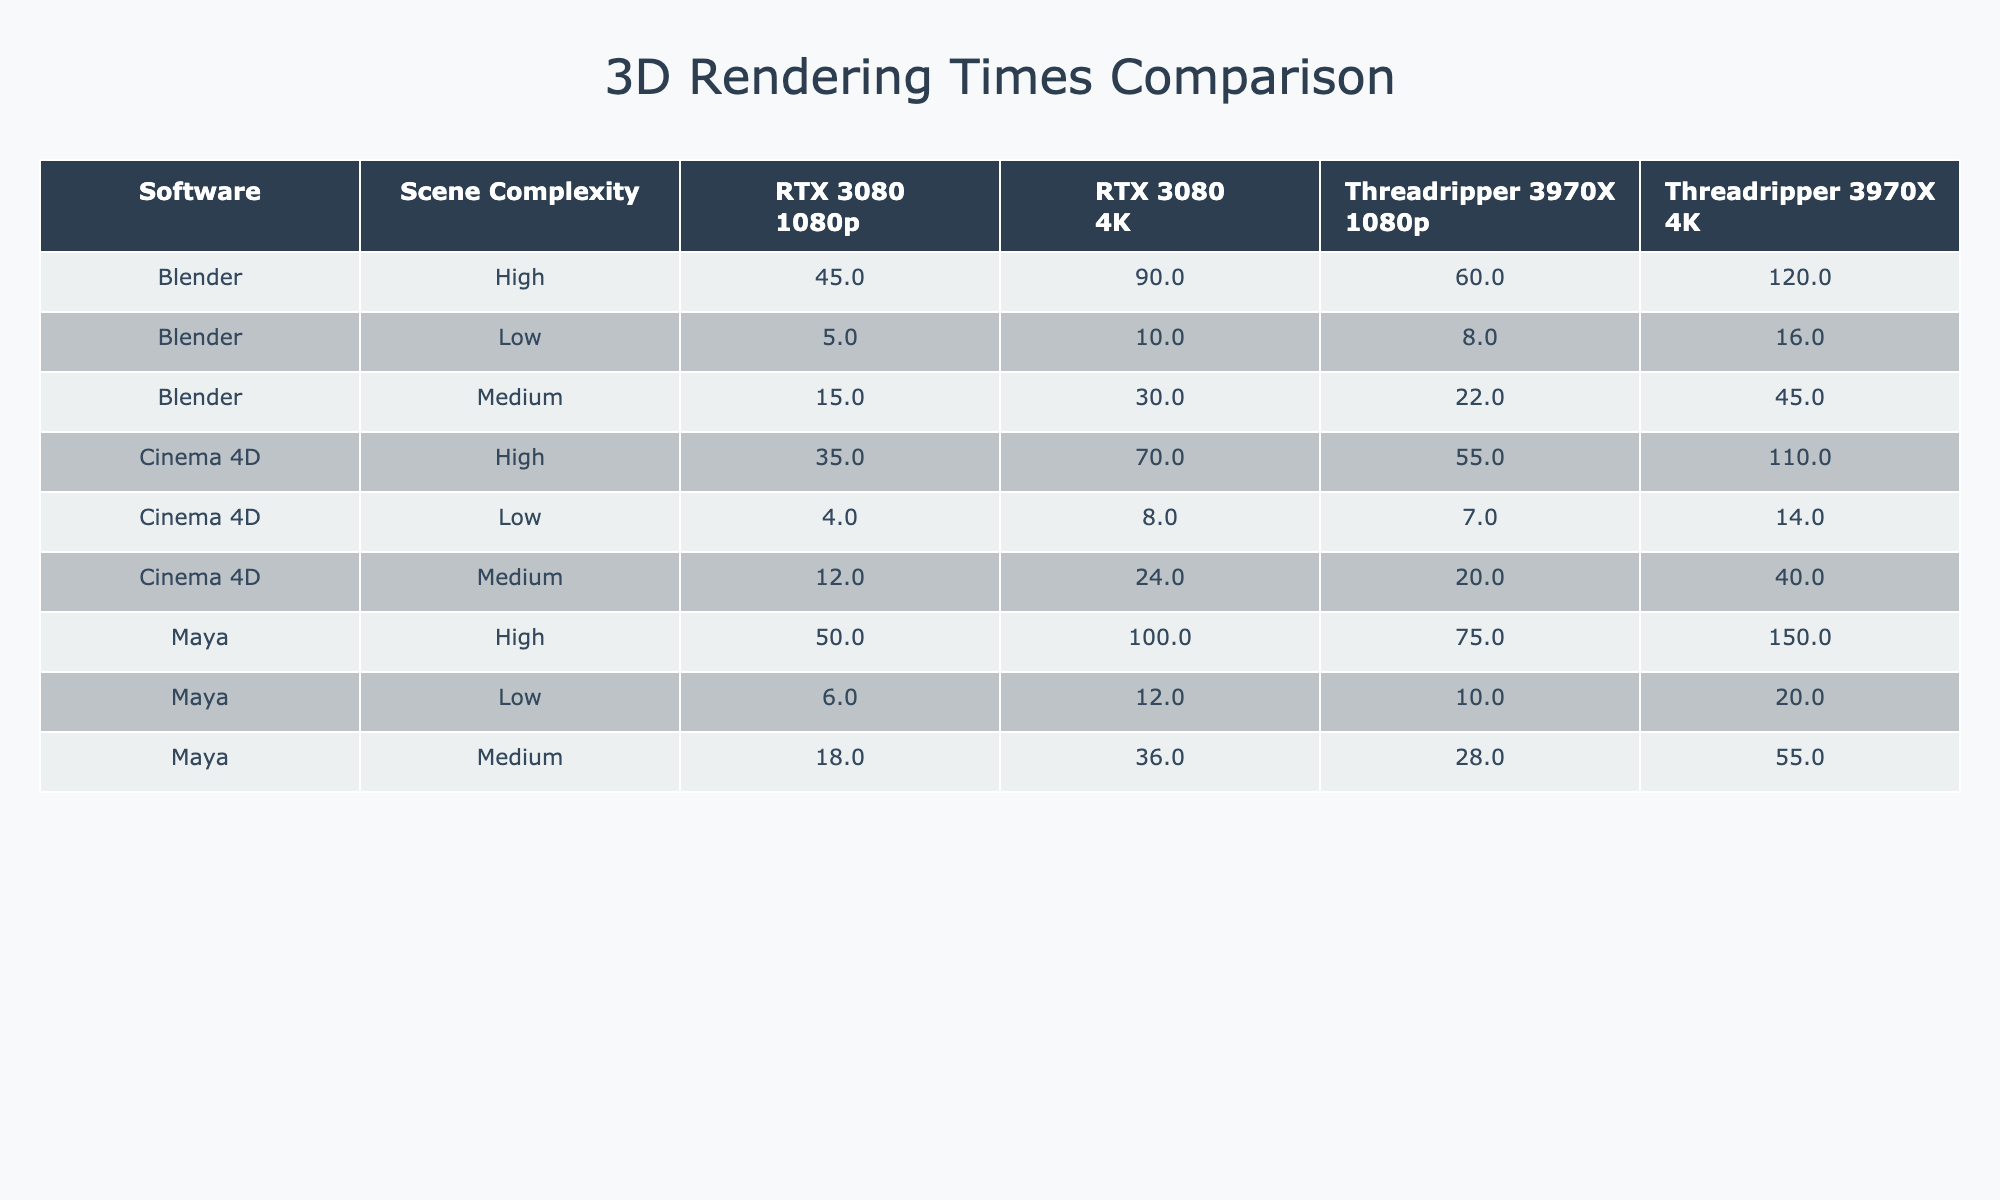What is the render time for Blender at low scene complexity with RTX 3080 in 1080p? The table shows that the render time for Blender with Low scene complexity using RTX 3080 in 1080p is 5 minutes.
Answer: 5 minutes Which software has the highest render time for high scene complexity at 4K resolution? By comparing the high scene complexity times across all software at 4K, Blender has a render time of 90 minutes, Maya 100 minutes, and Cinema 4D 70 minutes. The highest is for Maya at 100 minutes.
Answer: Maya What is the average render time for Cinema 4D at medium complexity across both hardware types? For Cinema 4D, the medium render times are 12 minutes (RTX 3080) and 20 minutes (Threadripper 3970X). The average is calculated as (12 + 20) / 2 = 16 minutes.
Answer: 16 minutes Do both RTX 3080 and Threadripper 3970X perform better for rendering Blender at low scene complexity? When comparing the low scene complexity render times for Blender, RTX 3080 takes 5 minutes while Threadripper 3970X takes 8 minutes. Since RTX 3080 is faster, the statement is true for RTX 3080 but false for Threadripper compared to itself. Thus, yes for RTX 3080 and no for Threadripper 3970X.
Answer: Yes for RTX, No for Threadripper What is the difference in render time for Maya at high complexity between RTX 3080 and Threadripper 3970X? From the table, Maya has a high scene complexity render time of 50 minutes with RTX 3080 and 75 minutes with Threadripper 3970X. The difference is calculated as 75 - 50 = 25 minutes.
Answer: 25 minutes Which hardware has the lowest render time for low scene complexity across all software? Examining the low scene complexity render times: Blender (RTX 3080: 5 min, Threadripper: 8 min), Maya (RTX 3080: 6 min, Threadripper: 10 min), and Cinema 4D (RTX 3080: 4 min, Threadripper: 7 min). Cinema 4D with RTX 3080 has the lowest time at 4 minutes.
Answer: Cinema 4D with RTX 3080 Is the render time for medium scene complexity in 4K resolution higher for Blender than for Cinema 4D? Checking the table: Blender has a render time of 30 minutes (RTX 3080) and 45 minutes (Threadripper 3970X) for medium 4K, while Cinema 4D has 24 minutes (RTX 3080) and 40 minutes (Threadripper 3970X). Both Blender's render times are higher than those of Cinema 4D.
Answer: Yes What is the total render time for Blender at high scene complexity in both 1080p and 4K? Blender has a high scene complexity render time of 45 minutes at 1080p and 90 minutes at 4K. The total is 45 + 90 = 135 minutes.
Answer: 135 minutes 